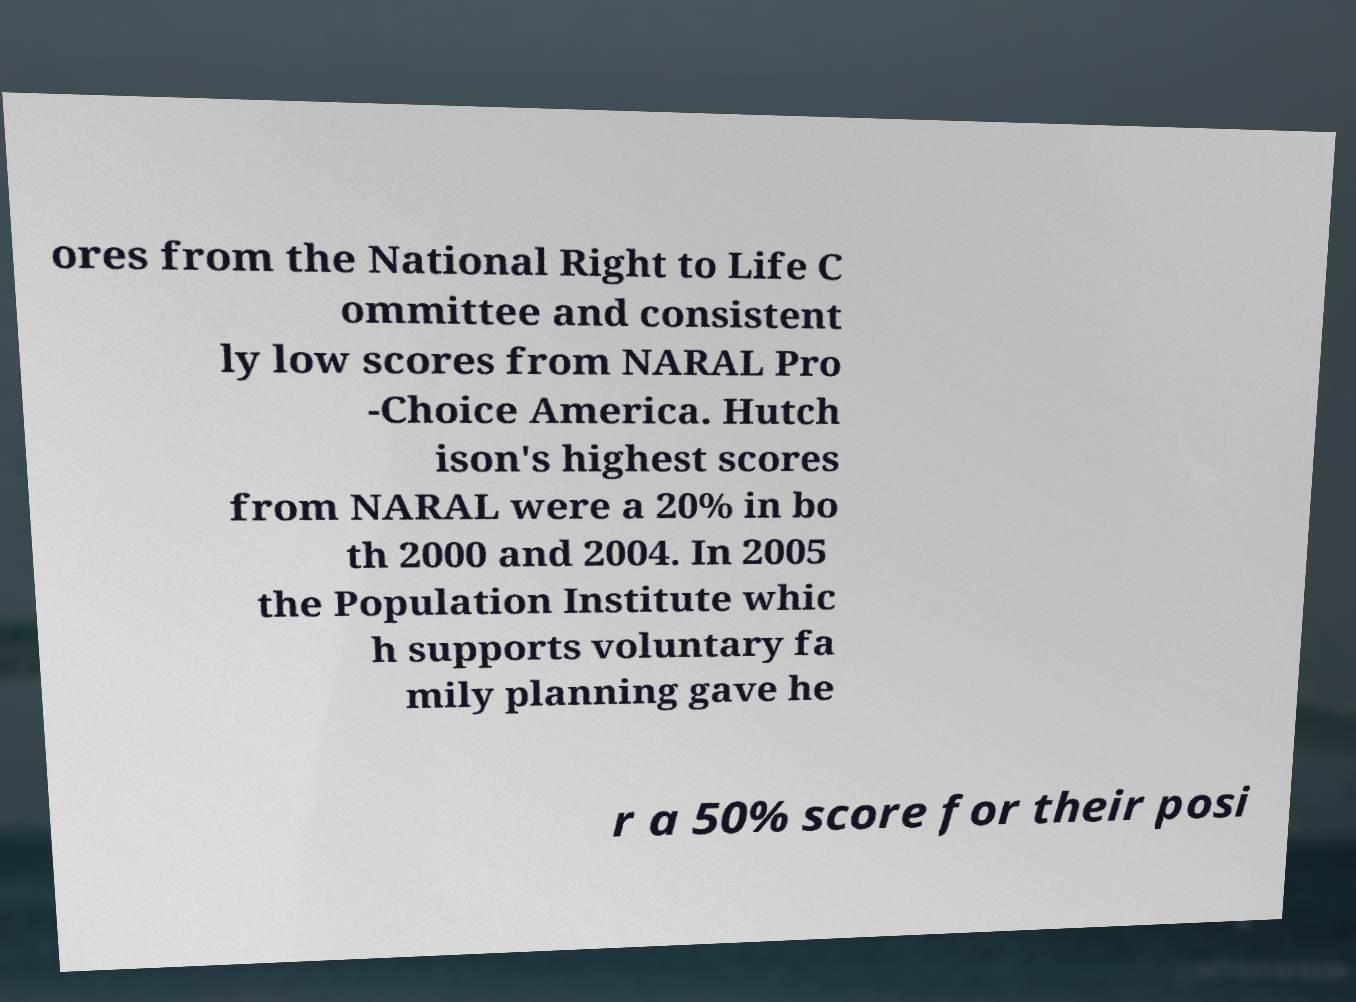Please read and relay the text visible in this image. What does it say? ores from the National Right to Life C ommittee and consistent ly low scores from NARAL Pro -Choice America. Hutch ison's highest scores from NARAL were a 20% in bo th 2000 and 2004. In 2005 the Population Institute whic h supports voluntary fa mily planning gave he r a 50% score for their posi 